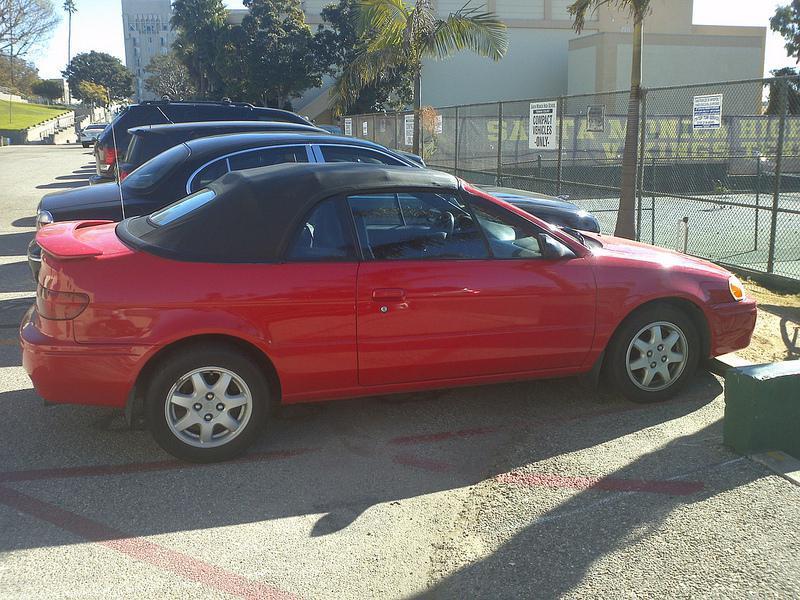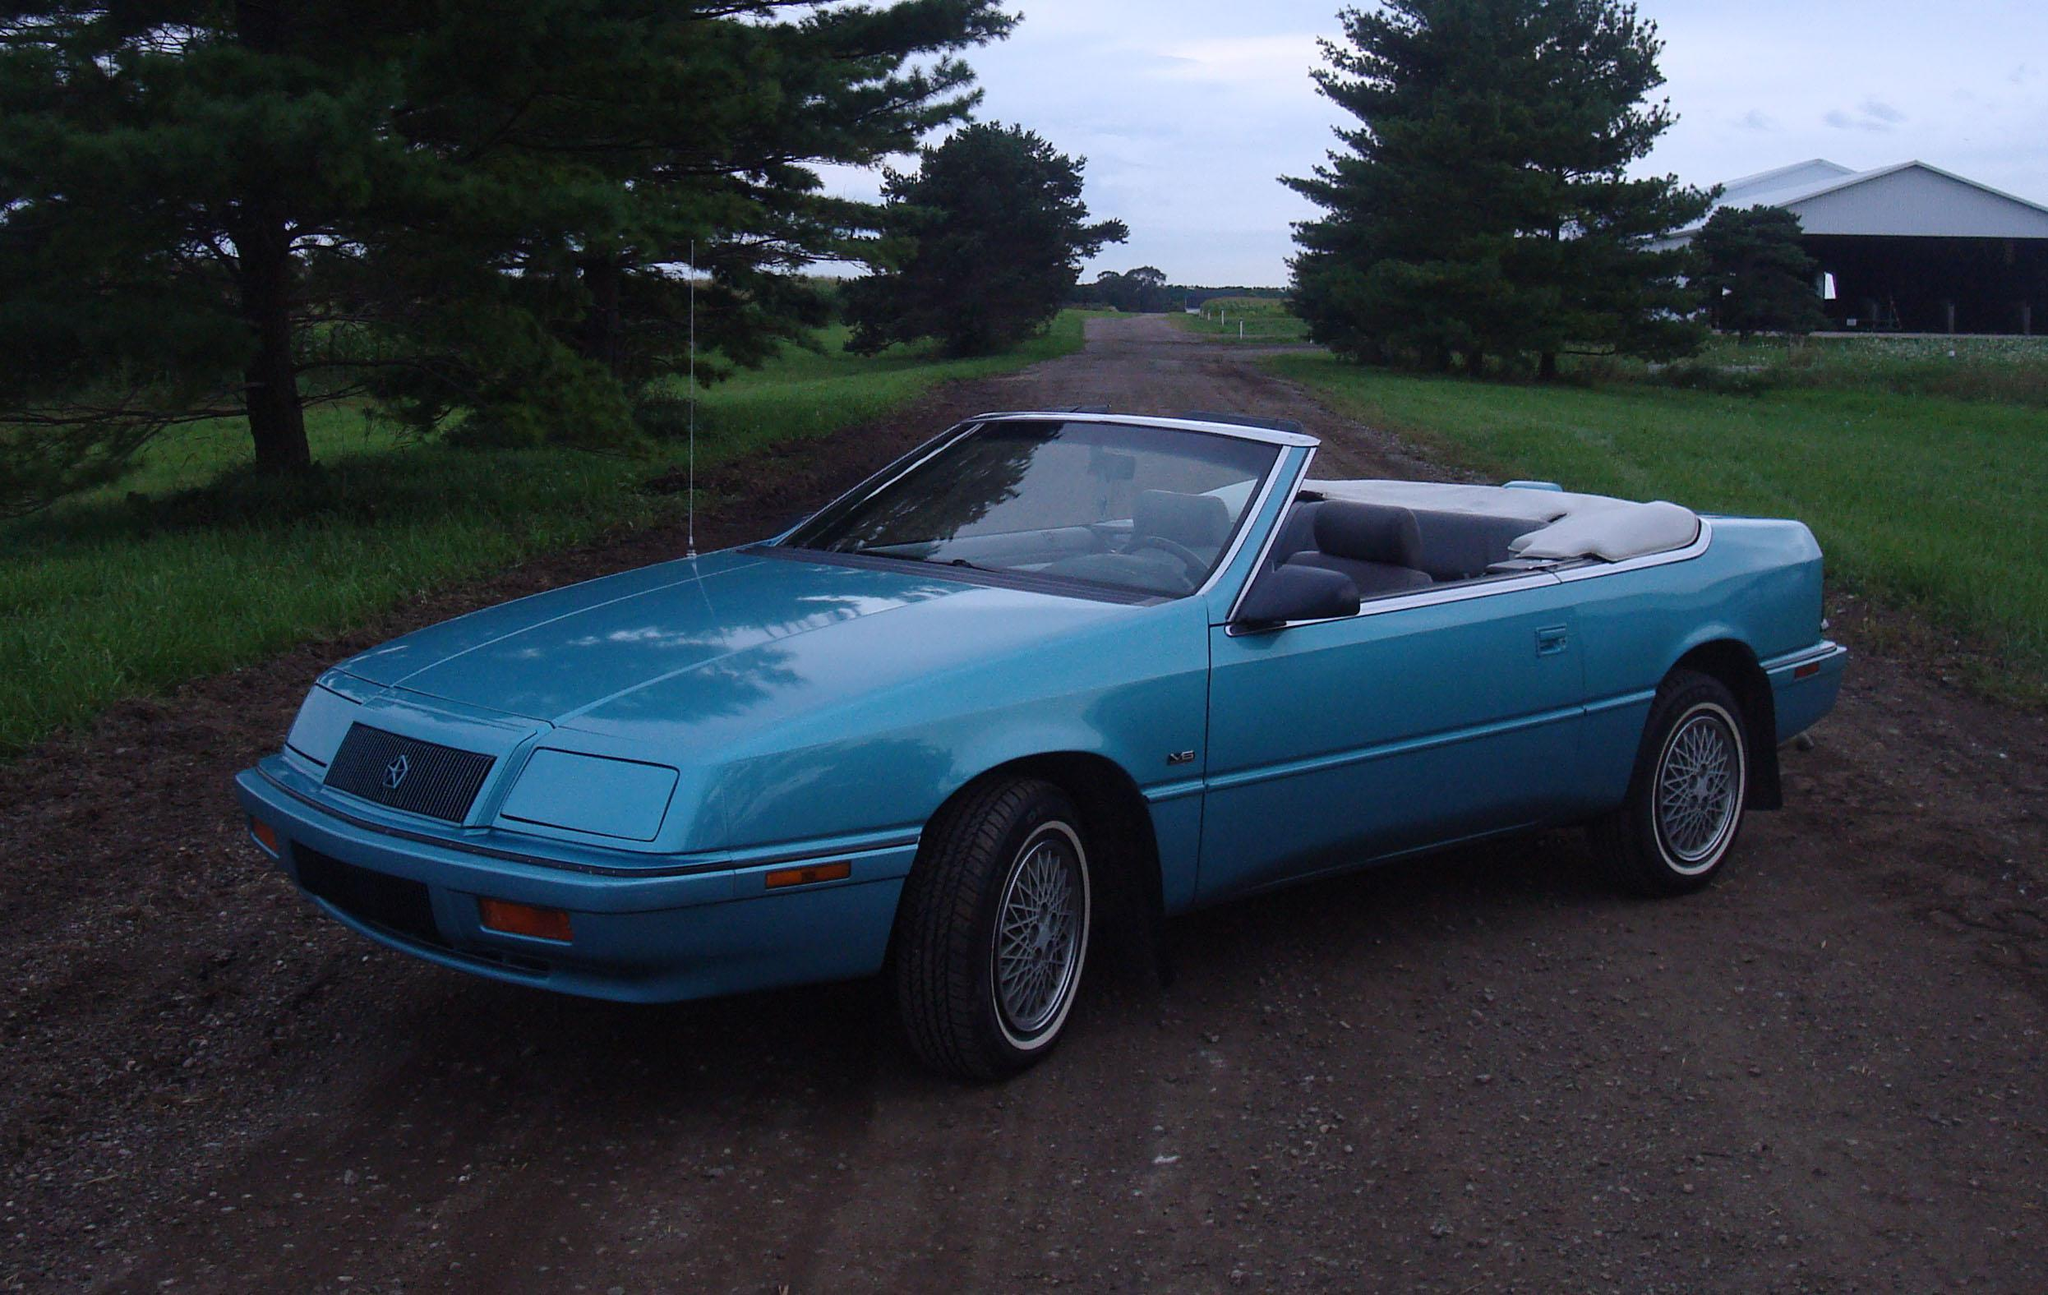The first image is the image on the left, the second image is the image on the right. Analyze the images presented: Is the assertion "An image shows a yellow car parked and facing leftward." valid? Answer yes or no. No. The first image is the image on the left, the second image is the image on the right. Considering the images on both sides, is "The car on the right has its top down." valid? Answer yes or no. Yes. 